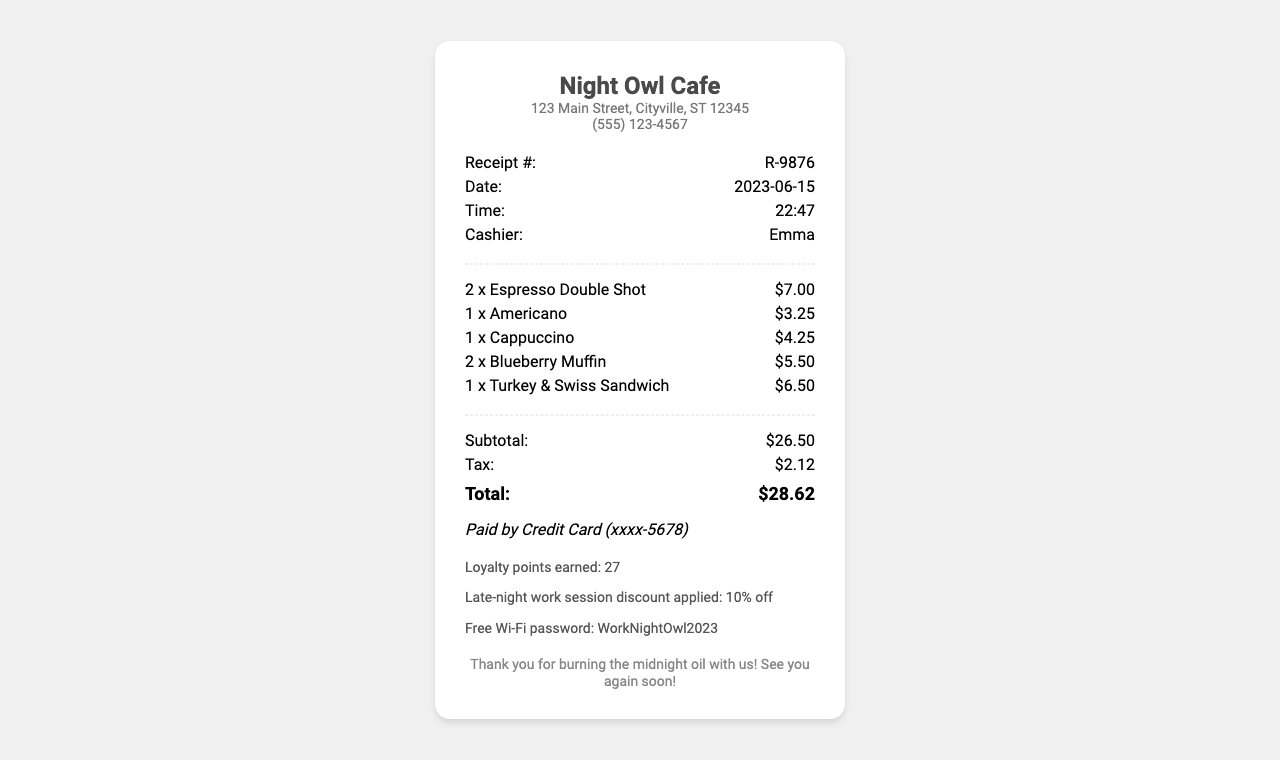What is the name of the coffee shop? The name of the coffee shop is mentioned at the top of the receipt, which is "Night Owl Cafe."
Answer: Night Owl Cafe What date was the receipt issued? The date of the receipt is provided in the details section, which reads "2023-06-15."
Answer: 2023-06-15 Who was the cashier for this transaction? The cashier's name is noted in the details section, which states "Emma."
Answer: Emma What is the total amount spent? The total amount spent is indicated at the bottom of the receipt as "$28.62."
Answer: $28.62 How many espresso double shots were ordered? The quantity of espresso double shots is specified in the order list, which indicates "2."
Answer: 2 What special note was applied to the order? The special note regarding discounts states there is a "Late-night work session discount applied: 10% off."
Answer: Late-night work session discount applied: 10% off What food item was ordered along with coffee? The food item listed in the order is the "Turkey & Swiss Sandwich."
Answer: Turkey & Swiss Sandwich How many loyalty points were earned? The number of loyalty points earned is specified in the notes section, which is "27."
Answer: 27 What time was the order placed? The order time is shown in the details section of the receipt, which indicates "22:47."
Answer: 22:47 